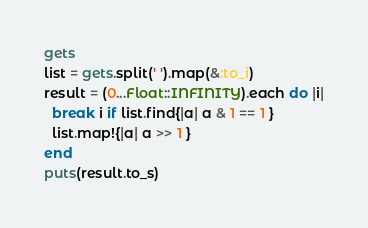Convert code to text. <code><loc_0><loc_0><loc_500><loc_500><_Ruby_>gets
list = gets.split(' ').map(&:to_i)
result = (0...Float::INFINITY).each do |i|
  break i if list.find{|a| a & 1 == 1 }
  list.map!{|a| a >> 1 }
end
puts(result.to_s)
</code> 